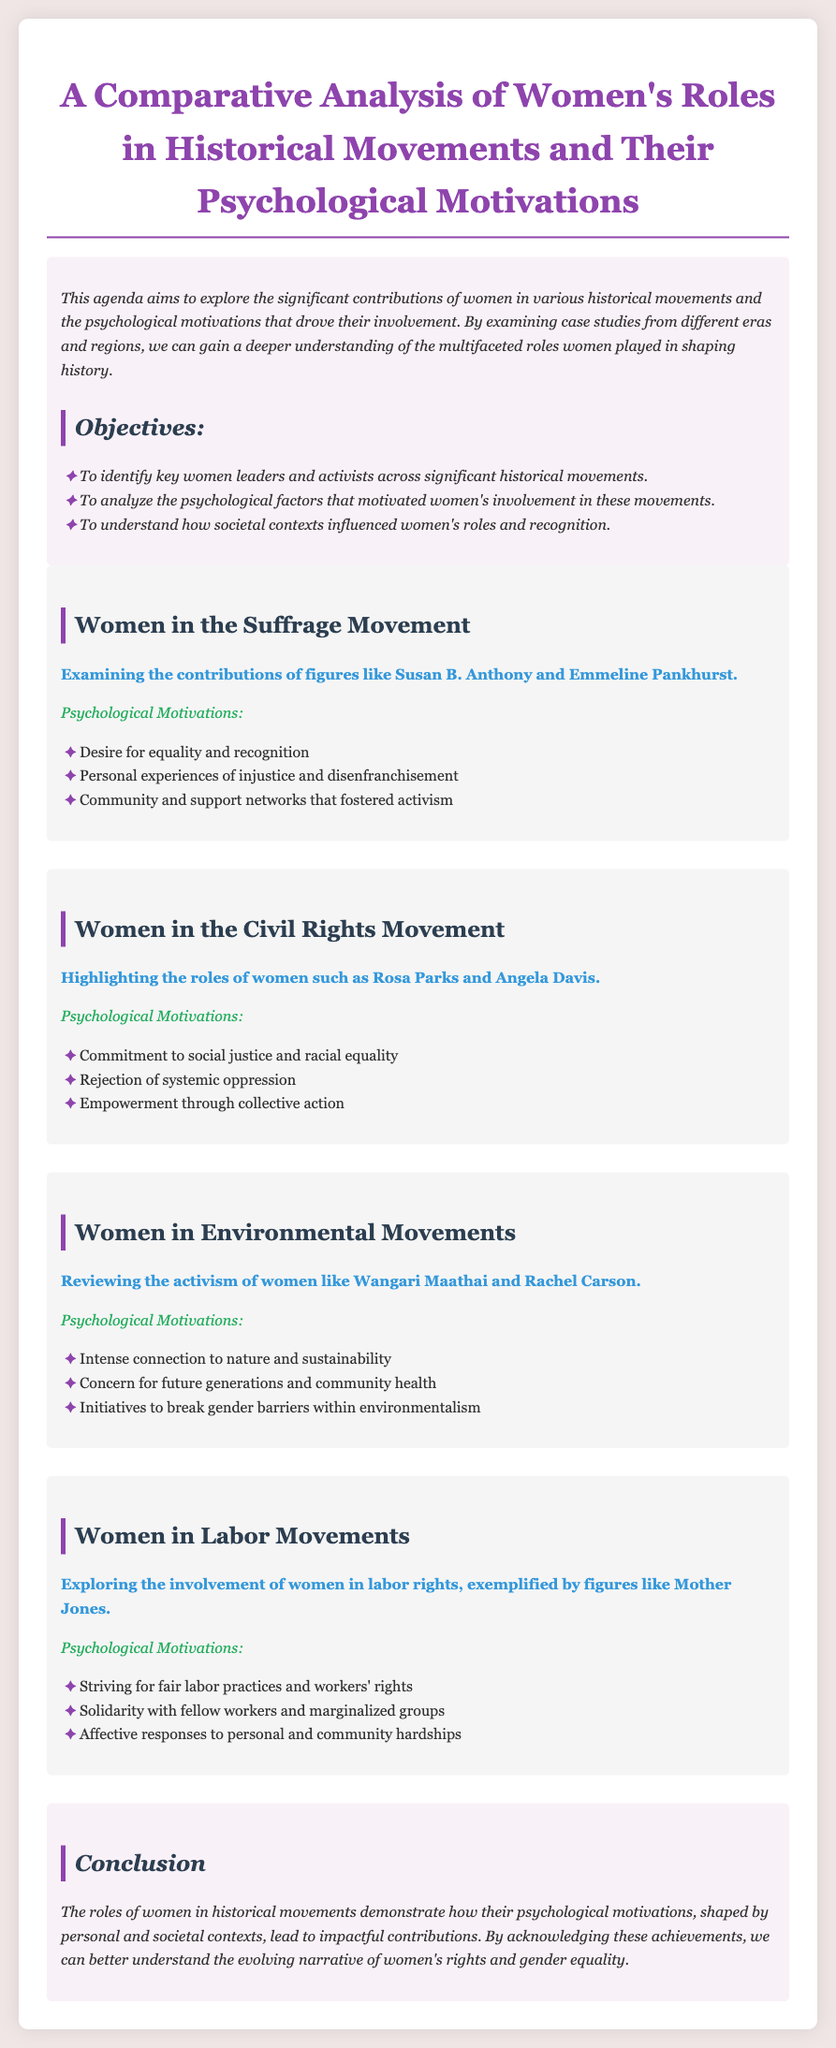What is the title of the document? The title is prominently displayed at the top of the document and reads "A Comparative Analysis of Women's Roles in Historical Movements and Their Psychological Motivations."
Answer: A Comparative Analysis of Women's Roles in Historical Movements and Their Psychological Motivations Who is a notable leader in the Suffrage Movement mentioned in the document? The document lists figures from the Suffrage Movement, specifically mentioning Susan B. Anthony and Emmeline Pankhurst.
Answer: Susan B. Anthony What psychological motivation is associated with women in the Civil Rights Movement? Several motivations are mentioned; one is "Commitment to social justice and racial equality," reflecting the reasons women participated in this movement.
Answer: Commitment to social justice and racial equality Which woman is highlighted in the Environmental Movements section? The document mentions prominent activists in environmental movements, specifically naming Wangari Maathai and Rachel Carson.
Answer: Wangari Maathai What does the document conclude about women's roles in historical movements? The conclusion summarizes the findings, asserting that women's roles demonstrate psychological motivations and contributions to history, emphasizing recognition of their achievements.
Answer: Their psychological motivations led to impactful contributions What societal context is mentioned affecting women's roles? The analysis details how personal and societal contexts influenced motivations and recognized women's contributions, indicating where they operated historically.
Answer: Societal contexts In which movement does Mother Jones exemplify women's involvement? The document focuses on labor rights and lists Mother Jones as a key figure under the Labor Movements section.
Answer: Labor Movements What type of document is this? The structure and content indicate that this is an agenda aimed at exploring historical analysis, focusing specifically on women's contributions to social movements.
Answer: Agenda 